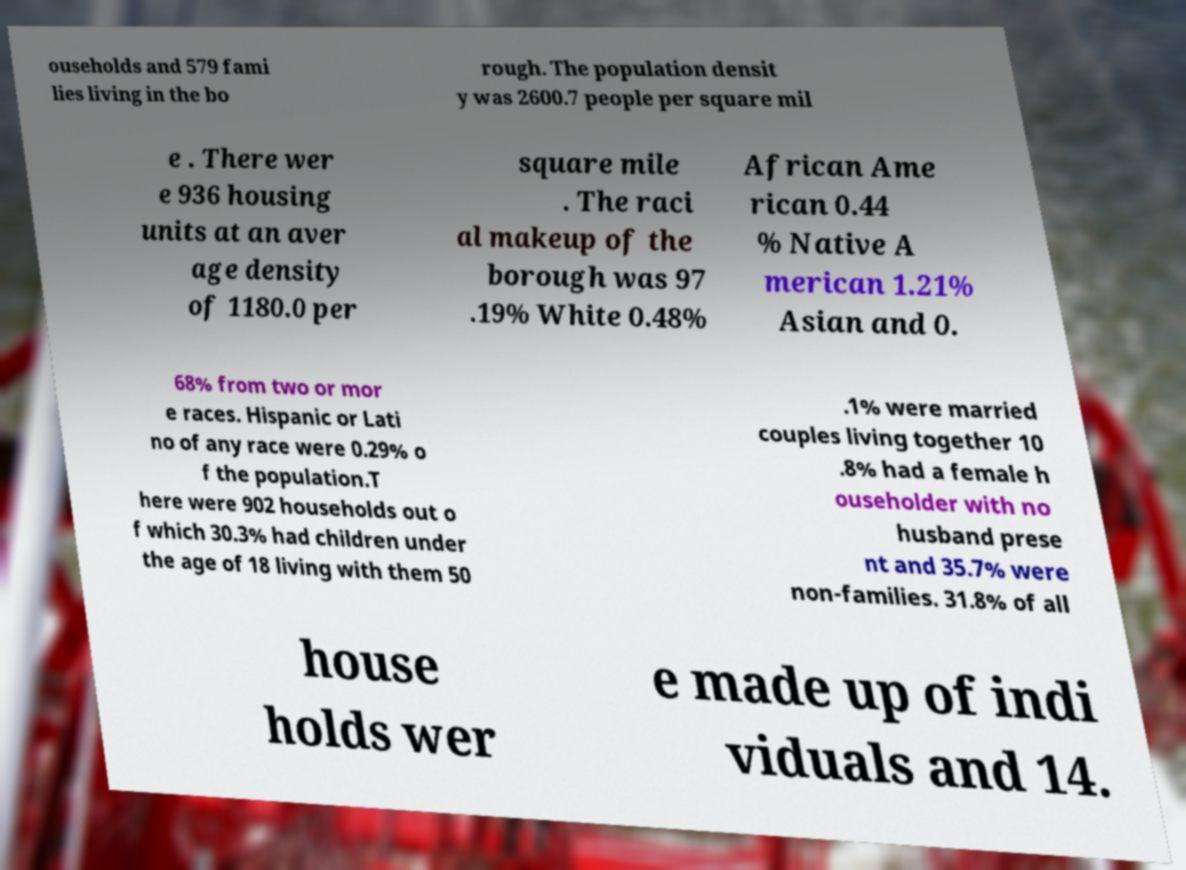Please identify and transcribe the text found in this image. ouseholds and 579 fami lies living in the bo rough. The population densit y was 2600.7 people per square mil e . There wer e 936 housing units at an aver age density of 1180.0 per square mile . The raci al makeup of the borough was 97 .19% White 0.48% African Ame rican 0.44 % Native A merican 1.21% Asian and 0. 68% from two or mor e races. Hispanic or Lati no of any race were 0.29% o f the population.T here were 902 households out o f which 30.3% had children under the age of 18 living with them 50 .1% were married couples living together 10 .8% had a female h ouseholder with no husband prese nt and 35.7% were non-families. 31.8% of all house holds wer e made up of indi viduals and 14. 